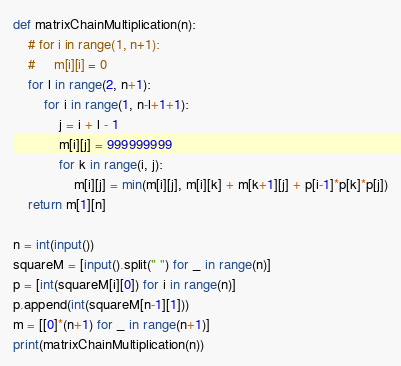<code> <loc_0><loc_0><loc_500><loc_500><_Python_>def matrixChainMultiplication(n):
    # for i in range(1, n+1):
    #     m[i][i] = 0
    for l in range(2, n+1):
        for i in range(1, n-l+1+1):
            j = i + l - 1
            m[i][j] = 999999999
            for k in range(i, j):
                m[i][j] = min(m[i][j], m[i][k] + m[k+1][j] + p[i-1]*p[k]*p[j])
    return m[1][n]

n = int(input())
squareM = [input().split(" ") for _ in range(n)]
p = [int(squareM[i][0]) for i in range(n)]
p.append(int(squareM[n-1][1]))
m = [[0]*(n+1) for _ in range(n+1)]
print(matrixChainMultiplication(n))
</code> 